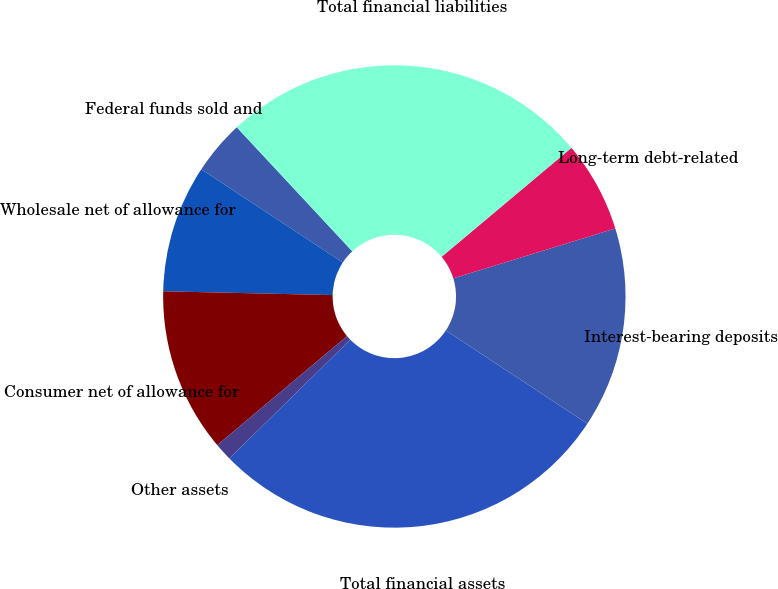Convert chart. <chart><loc_0><loc_0><loc_500><loc_500><pie_chart><fcel>Federal funds sold and<fcel>Wholesale net of allowance for<fcel>Consumer net of allowance for<fcel>Other assets<fcel>Total financial assets<fcel>Interest-bearing deposits<fcel>Long-term debt-related<fcel>Total financial liabilities<nl><fcel>3.8%<fcel>8.91%<fcel>11.47%<fcel>1.24%<fcel>28.37%<fcel>14.03%<fcel>6.36%<fcel>25.82%<nl></chart> 